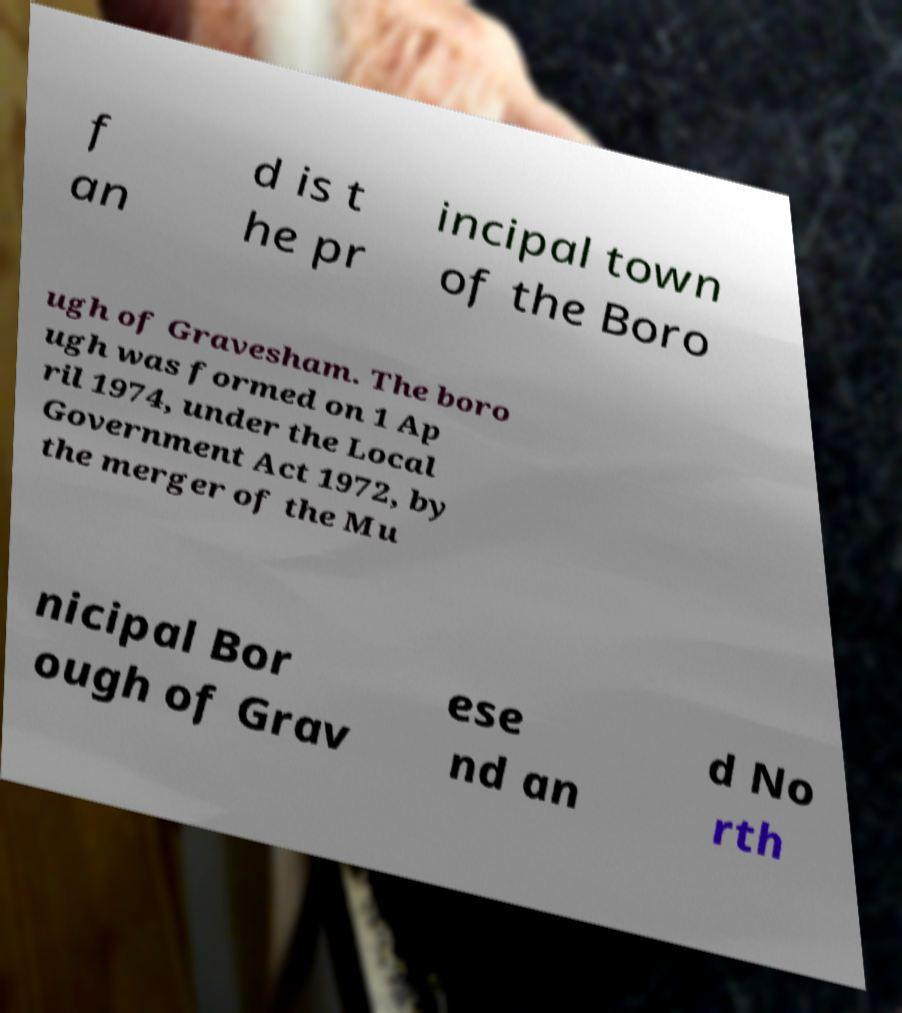There's text embedded in this image that I need extracted. Can you transcribe it verbatim? f an d is t he pr incipal town of the Boro ugh of Gravesham. The boro ugh was formed on 1 Ap ril 1974, under the Local Government Act 1972, by the merger of the Mu nicipal Bor ough of Grav ese nd an d No rth 